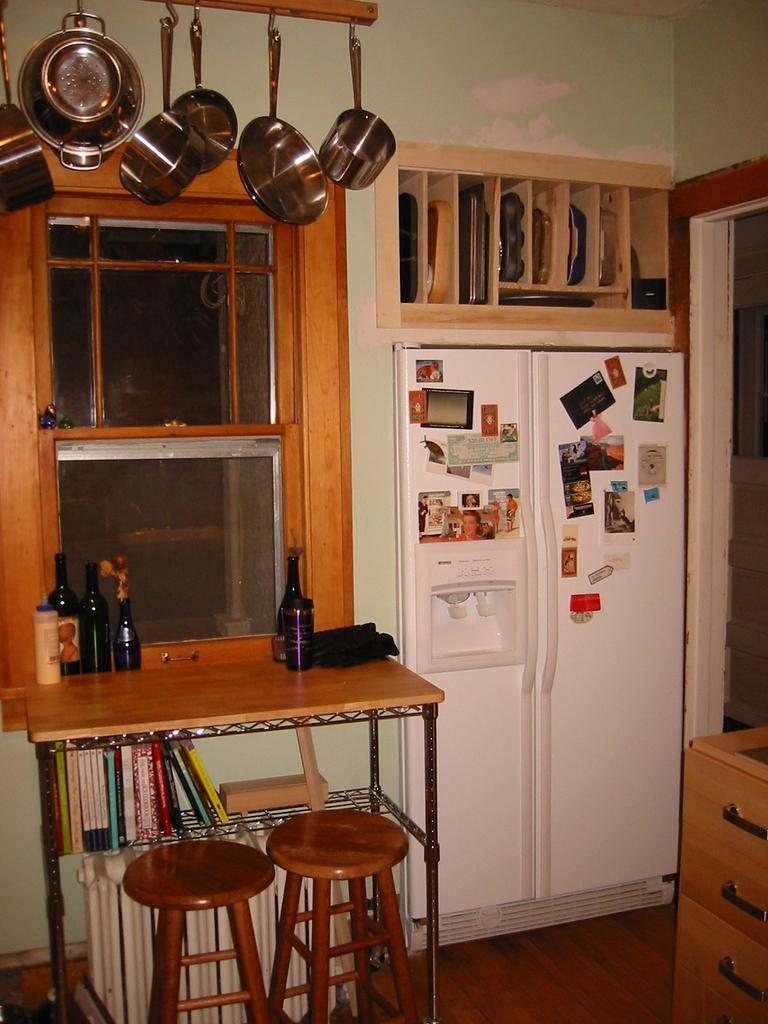What type of space is depicted in the image? There is a room in the image. What piece of furniture can be seen in the room? There is a table in the room. What is placed on the table? There are bottles on the table. What type of seating is available near the table? There are stools beside the table. What feature allows natural light into the room? There is a window in the room. What appliance is present in the room? There is a refrigerator in the room. What decorations are on the refrigerator? The refrigerator has stickers on it. What is hanging above the table? There are vessels hanging above the table. What type of education can be seen taking place in the image? There is no indication of education or any educational activities taking place in the image. 